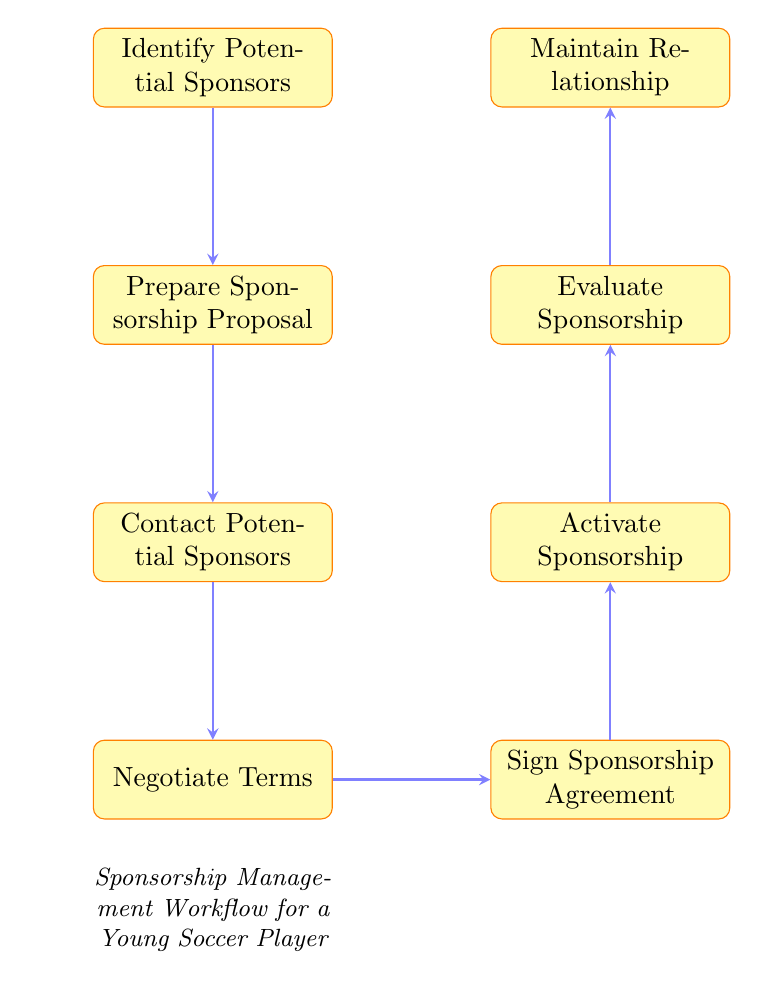What is the first step in the Sponsorship Management Workflow? The first step is identified directly in the diagram as "Identify Potential Sponsors." It is the node at the top of the flowchart and initiates the process.
Answer: Identify Potential Sponsors How many nodes are in the diagram? To find the total number of nodes, we look at each unique step in the workflow. By counting each rectangular node listed (each representing a different step), we find there are a total of eight nodes.
Answer: 8 What comes after "Prepare Sponsorship Proposal"? Following the node "Prepare Sponsorship Proposal," the diagram indicates the next node is "Contact Potential Sponsors." This is found directly below the proposal node in the flow.
Answer: Contact Potential Sponsors Which node represents the evaluation of the sponsorship? The evaluation of the sponsorship is represented by the node "Evaluate Sponsorship." This can be located near the end of the flow, prior to maintaining relationships.
Answer: Evaluate Sponsorship What is the last step in maintaining the relationship with sponsors? The last step in maintaining the relationship, as indicated in the diagram, is "Maintain Relationship." This is the final node at the top of the flowchart.
Answer: Maintain Relationship Which two steps are directly connected by an arrow? The steps directly connected by an arrow include many pairs, but specifically "Negotiate Terms" and "Sign Sponsorship Agreement." There's a direct downward connection from negotiating to signing visible in the flowchart.
Answer: Negotiate Terms and Sign Sponsorship Agreement How does one move from signing the sponsorship agreement to activating the sponsorship? The diagram shows a direct arrow from "Sign Sponsorship Agreement" to "Activate Sponsorship," indicating a sequential workflow. Signing the agreement leads to the activation of the sponsorship.
Answer: Sign Sponsorship Agreement to Activate Sponsorship What is the purpose of the proposal in the workflow? The purpose of the sponsorship proposal is summarized within its description as outlining benefits for sponsors, including branding opportunities and community engagement. This is the node that follows identifying sponsors.
Answer: Outline benefits for sponsors 